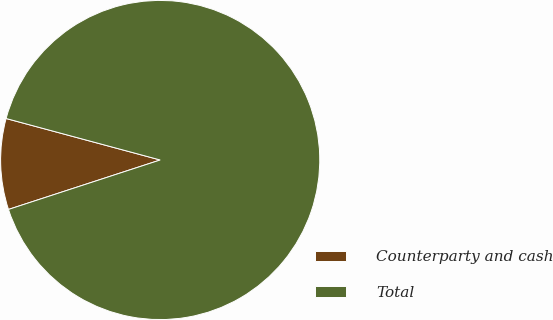Convert chart. <chart><loc_0><loc_0><loc_500><loc_500><pie_chart><fcel>Counterparty and cash<fcel>Total<nl><fcel>9.2%<fcel>90.8%<nl></chart> 